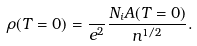Convert formula to latex. <formula><loc_0><loc_0><loc_500><loc_500>\rho ( T = 0 ) = \frac { } { e ^ { 2 } } \frac { N _ { i } A ( T = 0 ) } { n ^ { 1 / 2 } } .</formula> 